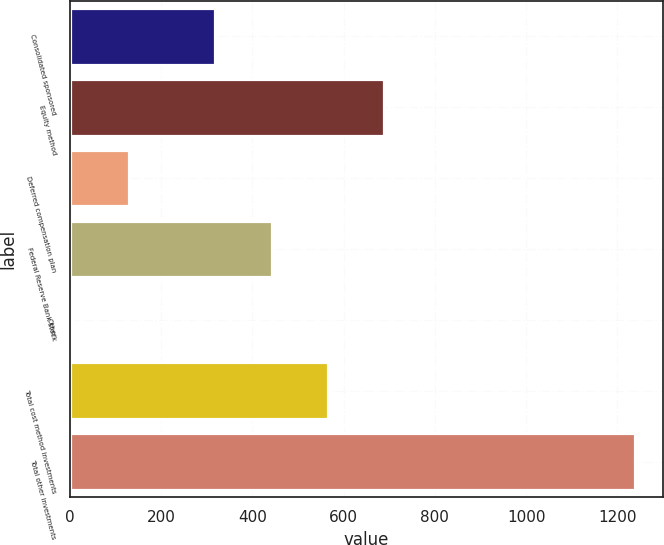<chart> <loc_0><loc_0><loc_500><loc_500><bar_chart><fcel>Consolidated sponsored<fcel>Equity method<fcel>Deferred compensation plan<fcel>Federal Reserve Bank stock<fcel>Other<fcel>Total cost method investments<fcel>Total other investments<nl><fcel>319<fcel>688.9<fcel>129.3<fcel>442.3<fcel>6<fcel>565.6<fcel>1239<nl></chart> 